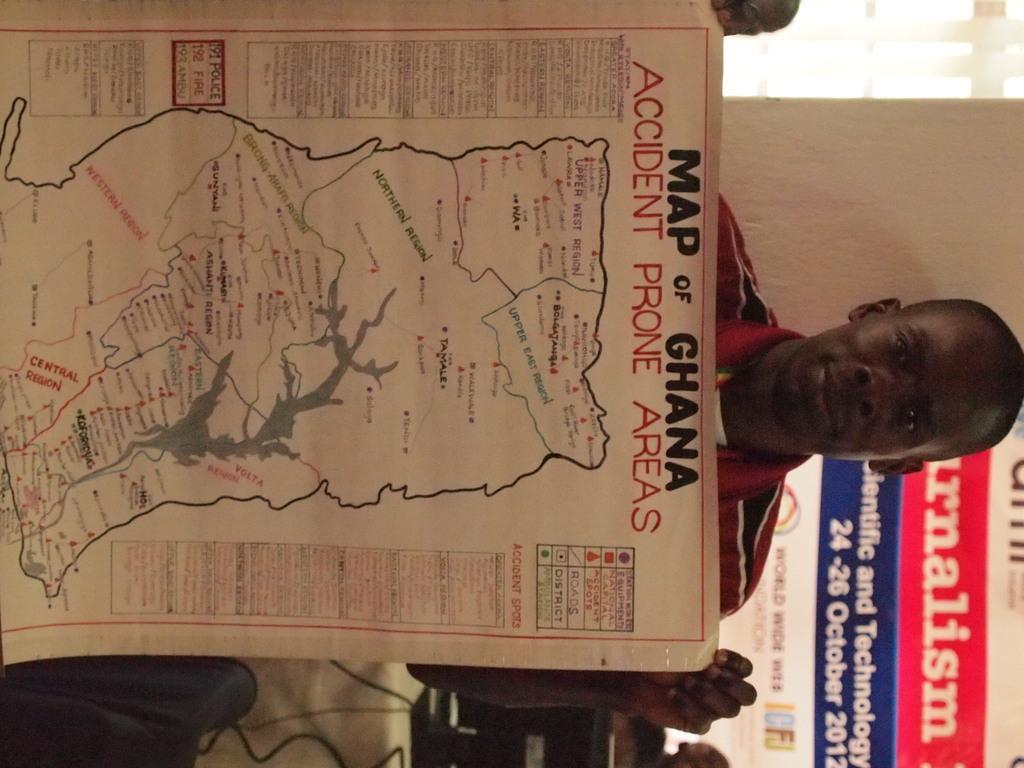In one or two sentences, can you explain what this image depicts? In this image there is one person standing and holding a map as we can see in middle of this image and there is a wall on the right side of this image and there is a chair on the bottom of this image. 